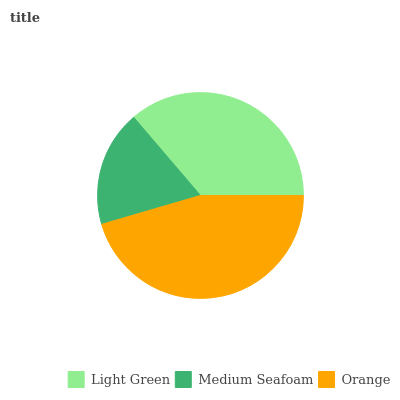Is Medium Seafoam the minimum?
Answer yes or no. Yes. Is Orange the maximum?
Answer yes or no. Yes. Is Orange the minimum?
Answer yes or no. No. Is Medium Seafoam the maximum?
Answer yes or no. No. Is Orange greater than Medium Seafoam?
Answer yes or no. Yes. Is Medium Seafoam less than Orange?
Answer yes or no. Yes. Is Medium Seafoam greater than Orange?
Answer yes or no. No. Is Orange less than Medium Seafoam?
Answer yes or no. No. Is Light Green the high median?
Answer yes or no. Yes. Is Light Green the low median?
Answer yes or no. Yes. Is Medium Seafoam the high median?
Answer yes or no. No. Is Medium Seafoam the low median?
Answer yes or no. No. 